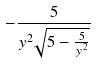<formula> <loc_0><loc_0><loc_500><loc_500>- \frac { 5 } { y ^ { 2 } \sqrt { 5 - \frac { 5 } { y ^ { 2 } } } }</formula> 